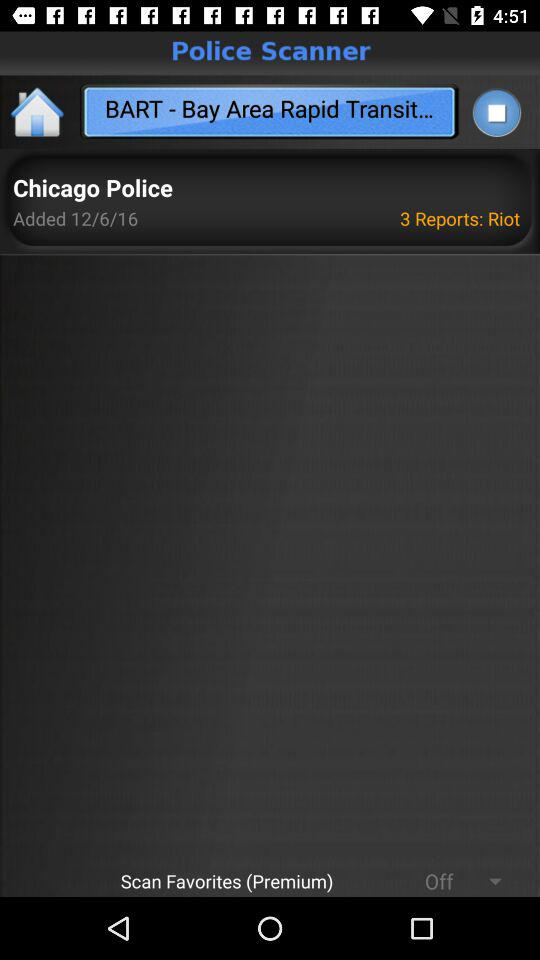What is the status of "Scan Favorites (Premium)"? The status is "off". 